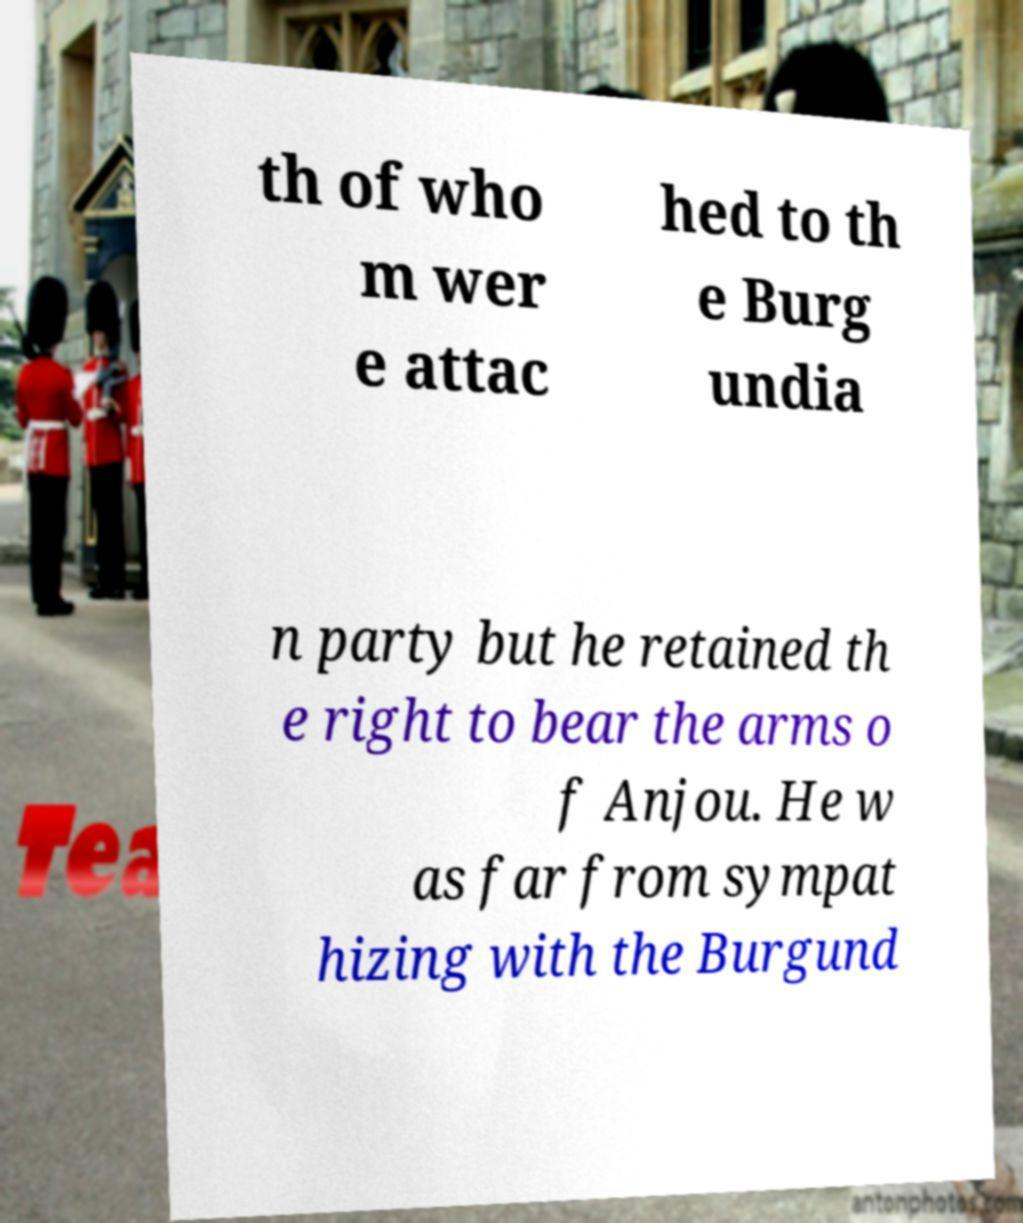I need the written content from this picture converted into text. Can you do that? th of who m wer e attac hed to th e Burg undia n party but he retained th e right to bear the arms o f Anjou. He w as far from sympat hizing with the Burgund 